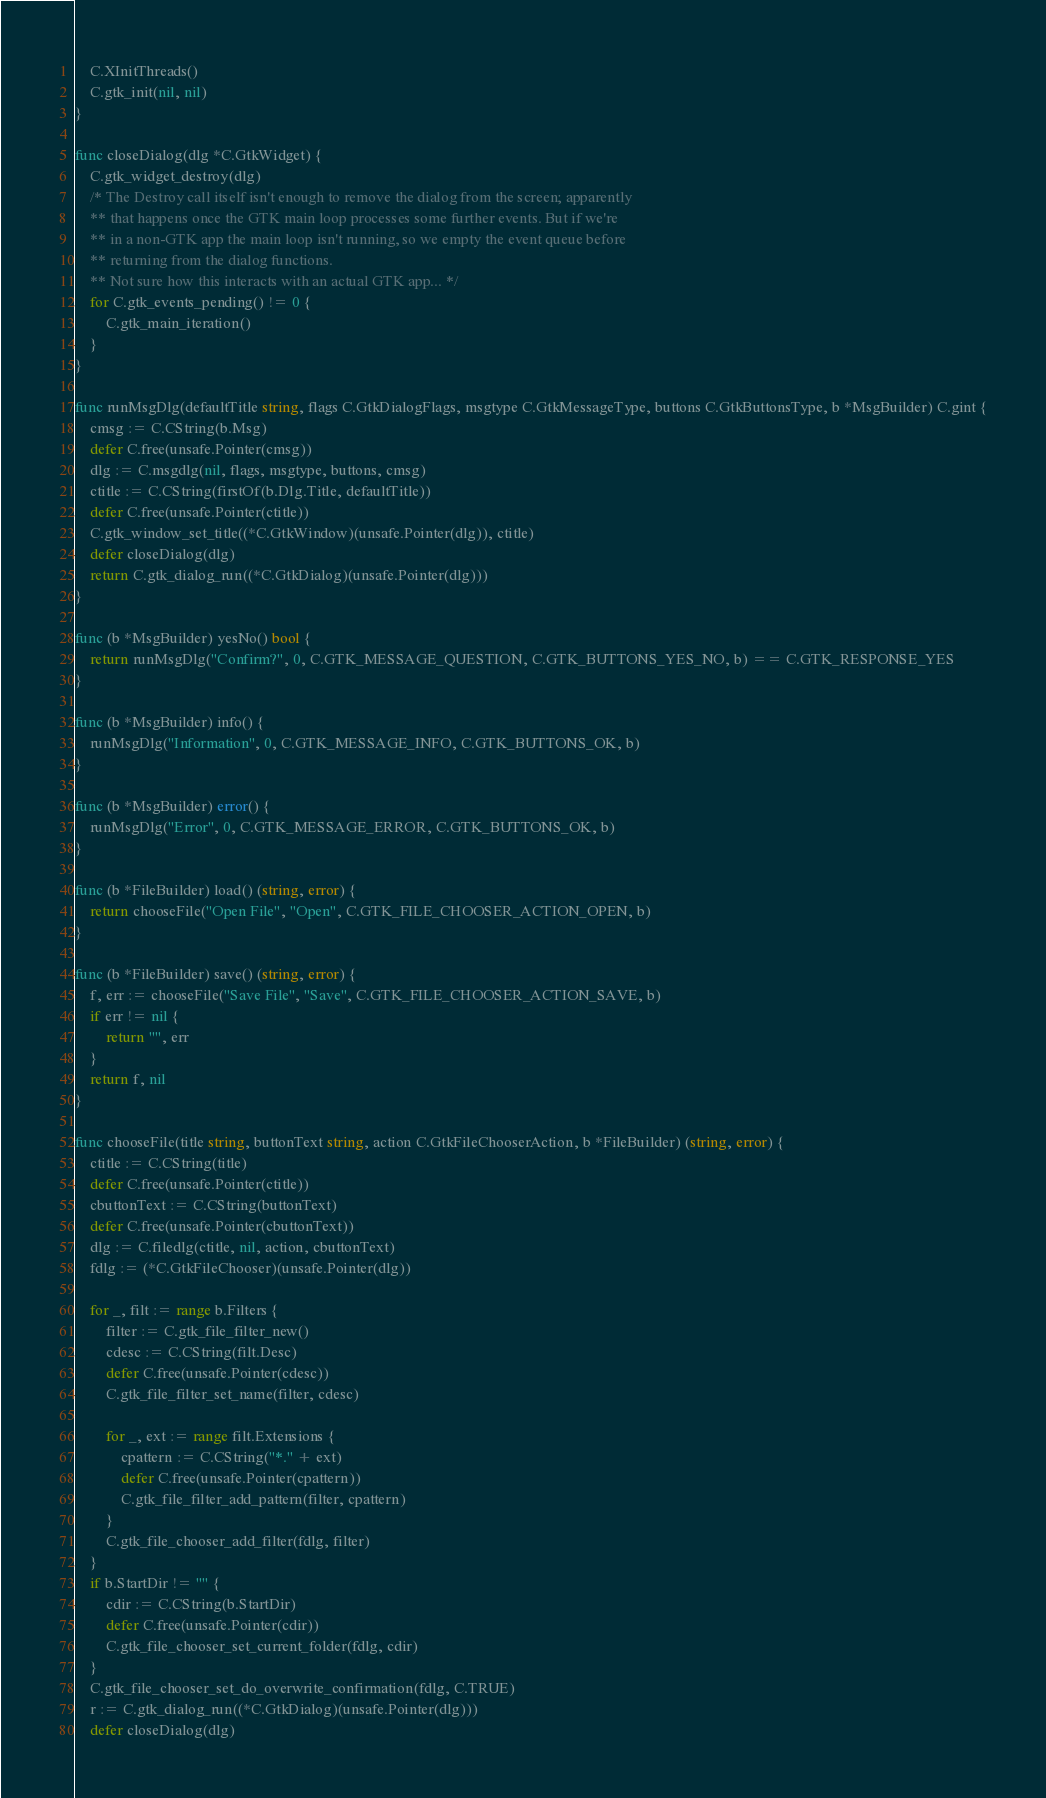Convert code to text. <code><loc_0><loc_0><loc_500><loc_500><_Go_>
	C.XInitThreads()
	C.gtk_init(nil, nil)
}

func closeDialog(dlg *C.GtkWidget) {
	C.gtk_widget_destroy(dlg)
	/* The Destroy call itself isn't enough to remove the dialog from the screen; apparently
	** that happens once the GTK main loop processes some further events. But if we're
	** in a non-GTK app the main loop isn't running, so we empty the event queue before
	** returning from the dialog functions.
	** Not sure how this interacts with an actual GTK app... */
	for C.gtk_events_pending() != 0 {
		C.gtk_main_iteration()
	}
}

func runMsgDlg(defaultTitle string, flags C.GtkDialogFlags, msgtype C.GtkMessageType, buttons C.GtkButtonsType, b *MsgBuilder) C.gint {
	cmsg := C.CString(b.Msg)
	defer C.free(unsafe.Pointer(cmsg))
	dlg := C.msgdlg(nil, flags, msgtype, buttons, cmsg)
	ctitle := C.CString(firstOf(b.Dlg.Title, defaultTitle))
	defer C.free(unsafe.Pointer(ctitle))
	C.gtk_window_set_title((*C.GtkWindow)(unsafe.Pointer(dlg)), ctitle)
	defer closeDialog(dlg)
	return C.gtk_dialog_run((*C.GtkDialog)(unsafe.Pointer(dlg)))
}

func (b *MsgBuilder) yesNo() bool {
	return runMsgDlg("Confirm?", 0, C.GTK_MESSAGE_QUESTION, C.GTK_BUTTONS_YES_NO, b) == C.GTK_RESPONSE_YES
}

func (b *MsgBuilder) info() {
	runMsgDlg("Information", 0, C.GTK_MESSAGE_INFO, C.GTK_BUTTONS_OK, b)
}

func (b *MsgBuilder) error() {
	runMsgDlg("Error", 0, C.GTK_MESSAGE_ERROR, C.GTK_BUTTONS_OK, b)
}

func (b *FileBuilder) load() (string, error) {
	return chooseFile("Open File", "Open", C.GTK_FILE_CHOOSER_ACTION_OPEN, b)
}

func (b *FileBuilder) save() (string, error) {
	f, err := chooseFile("Save File", "Save", C.GTK_FILE_CHOOSER_ACTION_SAVE, b)
	if err != nil {
		return "", err
	}
	return f, nil
}

func chooseFile(title string, buttonText string, action C.GtkFileChooserAction, b *FileBuilder) (string, error) {
	ctitle := C.CString(title)
	defer C.free(unsafe.Pointer(ctitle))
	cbuttonText := C.CString(buttonText)
	defer C.free(unsafe.Pointer(cbuttonText))
	dlg := C.filedlg(ctitle, nil, action, cbuttonText)
	fdlg := (*C.GtkFileChooser)(unsafe.Pointer(dlg))

	for _, filt := range b.Filters {
		filter := C.gtk_file_filter_new()
		cdesc := C.CString(filt.Desc)
		defer C.free(unsafe.Pointer(cdesc))
		C.gtk_file_filter_set_name(filter, cdesc)

		for _, ext := range filt.Extensions {
			cpattern := C.CString("*." + ext)
			defer C.free(unsafe.Pointer(cpattern))
			C.gtk_file_filter_add_pattern(filter, cpattern)
		}
		C.gtk_file_chooser_add_filter(fdlg, filter)
	}
	if b.StartDir != "" {
		cdir := C.CString(b.StartDir)
		defer C.free(unsafe.Pointer(cdir))
		C.gtk_file_chooser_set_current_folder(fdlg, cdir)
	}
	C.gtk_file_chooser_set_do_overwrite_confirmation(fdlg, C.TRUE)
	r := C.gtk_dialog_run((*C.GtkDialog)(unsafe.Pointer(dlg)))
	defer closeDialog(dlg)</code> 